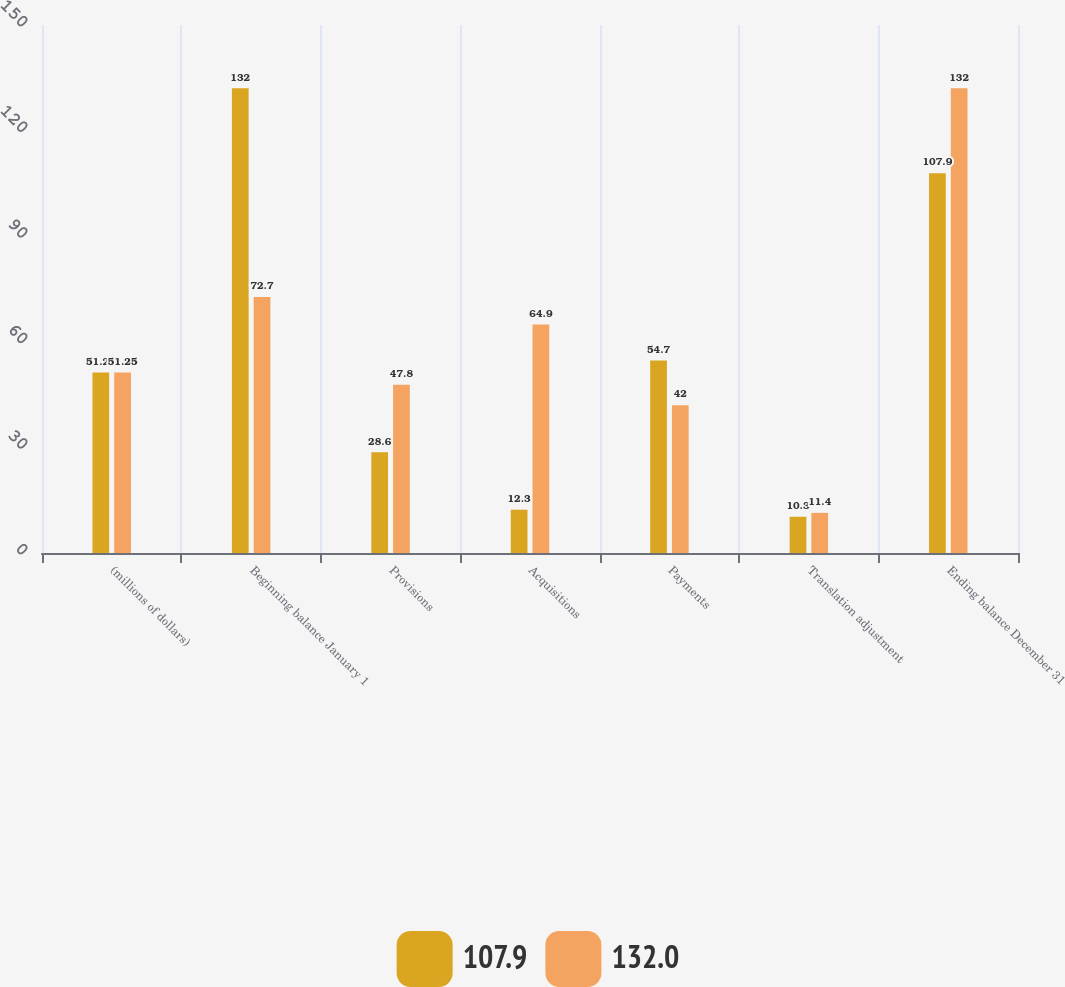Convert chart. <chart><loc_0><loc_0><loc_500><loc_500><stacked_bar_chart><ecel><fcel>(millions of dollars)<fcel>Beginning balance January 1<fcel>Provisions<fcel>Acquisitions<fcel>Payments<fcel>Translation adjustment<fcel>Ending balance December 31<nl><fcel>107.9<fcel>51.25<fcel>132<fcel>28.6<fcel>12.3<fcel>54.7<fcel>10.3<fcel>107.9<nl><fcel>132<fcel>51.25<fcel>72.7<fcel>47.8<fcel>64.9<fcel>42<fcel>11.4<fcel>132<nl></chart> 